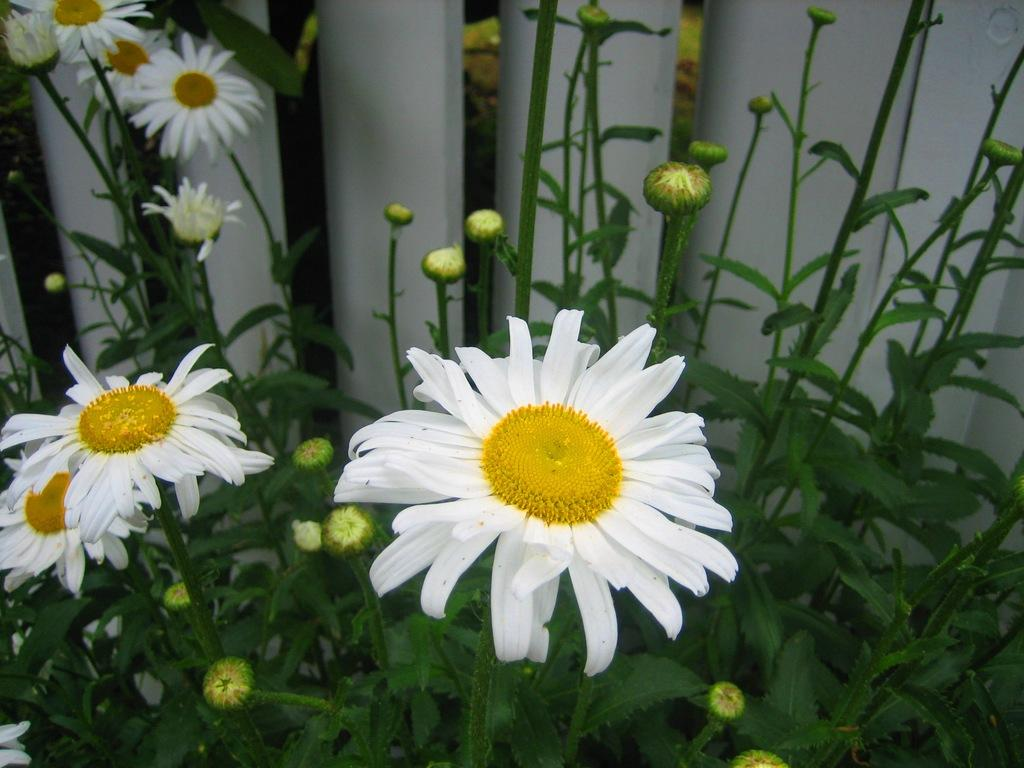What type of living organisms can be seen in the image? Plants can be seen in the image. What specific features can be observed on the plants? The plants have flowers, buds, and leaves on their stems. What is located behind the plants in the image? There is a fencing behind the plants. Can you describe the scene where the plants are jumping in the image? There is no scene of plants jumping in the image; the plants are stationary with flowers, buds, and leaves on their stems. 